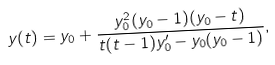<formula> <loc_0><loc_0><loc_500><loc_500>y ( t ) = y _ { 0 } + \frac { y _ { 0 } ^ { 2 } ( y _ { 0 } - 1 ) ( y _ { 0 } - t ) } { t ( t - 1 ) y _ { 0 } ^ { \prime } - y _ { 0 } ( y _ { 0 } - 1 ) } ,</formula> 